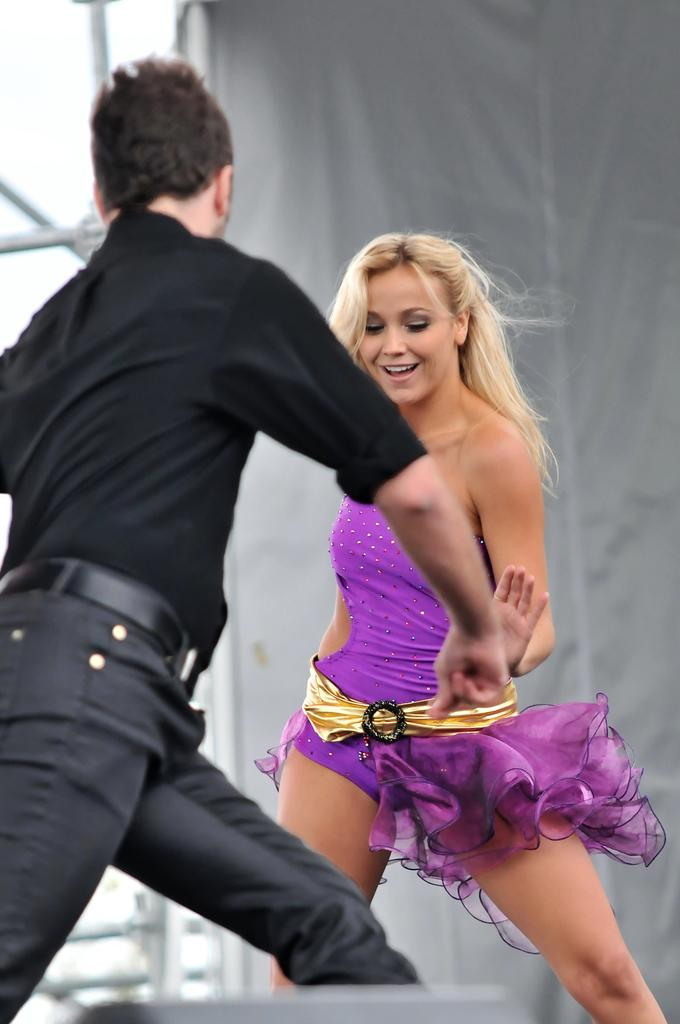What is present in the image? There is a man and a woman in the image. What is the woman doing in the image? The woman is smiling in the image. What can be seen in the background of the image? There are metal rods in the background of the image. How many cakes are being served by the girl in the church in the image? There is no girl or church present in the image, and no cakes are being served. 